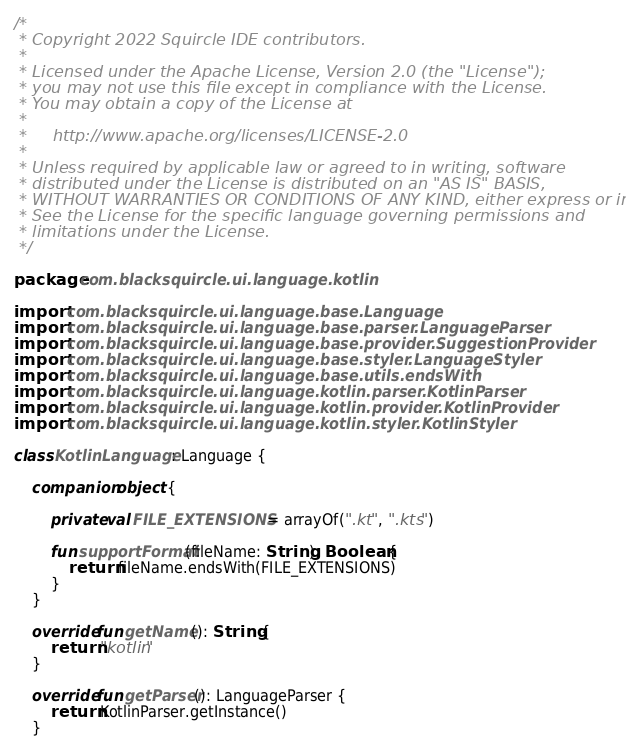Convert code to text. <code><loc_0><loc_0><loc_500><loc_500><_Kotlin_>/*
 * Copyright 2022 Squircle IDE contributors.
 *
 * Licensed under the Apache License, Version 2.0 (the "License");
 * you may not use this file except in compliance with the License.
 * You may obtain a copy of the License at
 *
 *     http://www.apache.org/licenses/LICENSE-2.0
 *
 * Unless required by applicable law or agreed to in writing, software
 * distributed under the License is distributed on an "AS IS" BASIS,
 * WITHOUT WARRANTIES OR CONDITIONS OF ANY KIND, either express or implied.
 * See the License for the specific language governing permissions and
 * limitations under the License.
 */

package com.blacksquircle.ui.language.kotlin

import com.blacksquircle.ui.language.base.Language
import com.blacksquircle.ui.language.base.parser.LanguageParser
import com.blacksquircle.ui.language.base.provider.SuggestionProvider
import com.blacksquircle.ui.language.base.styler.LanguageStyler
import com.blacksquircle.ui.language.base.utils.endsWith
import com.blacksquircle.ui.language.kotlin.parser.KotlinParser
import com.blacksquircle.ui.language.kotlin.provider.KotlinProvider
import com.blacksquircle.ui.language.kotlin.styler.KotlinStyler

class KotlinLanguage : Language {

    companion object {

        private val FILE_EXTENSIONS = arrayOf(".kt", ".kts")

        fun supportFormat(fileName: String): Boolean {
            return fileName.endsWith(FILE_EXTENSIONS)
        }
    }

    override fun getName(): String {
        return "kotlin"
    }

    override fun getParser(): LanguageParser {
        return KotlinParser.getInstance()
    }
</code> 